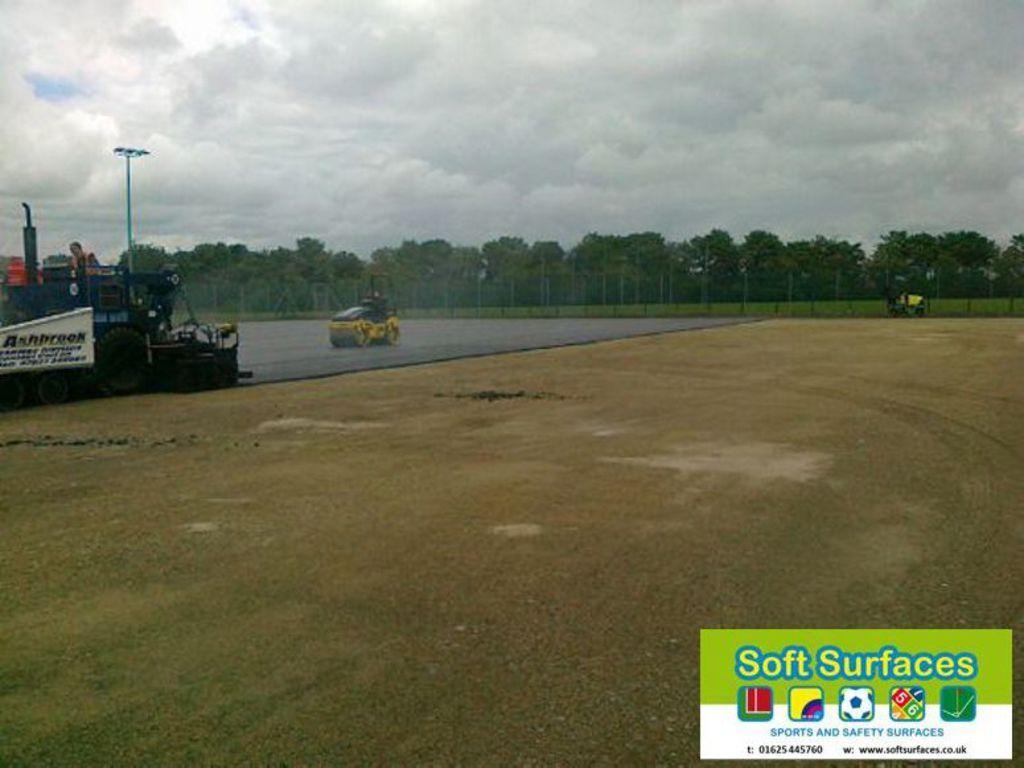Describe this image in one or two sentences. On the left there are two vehicles on the road. In the background we can see fence,an object,pole,trees,grass and clouds in the sky. 